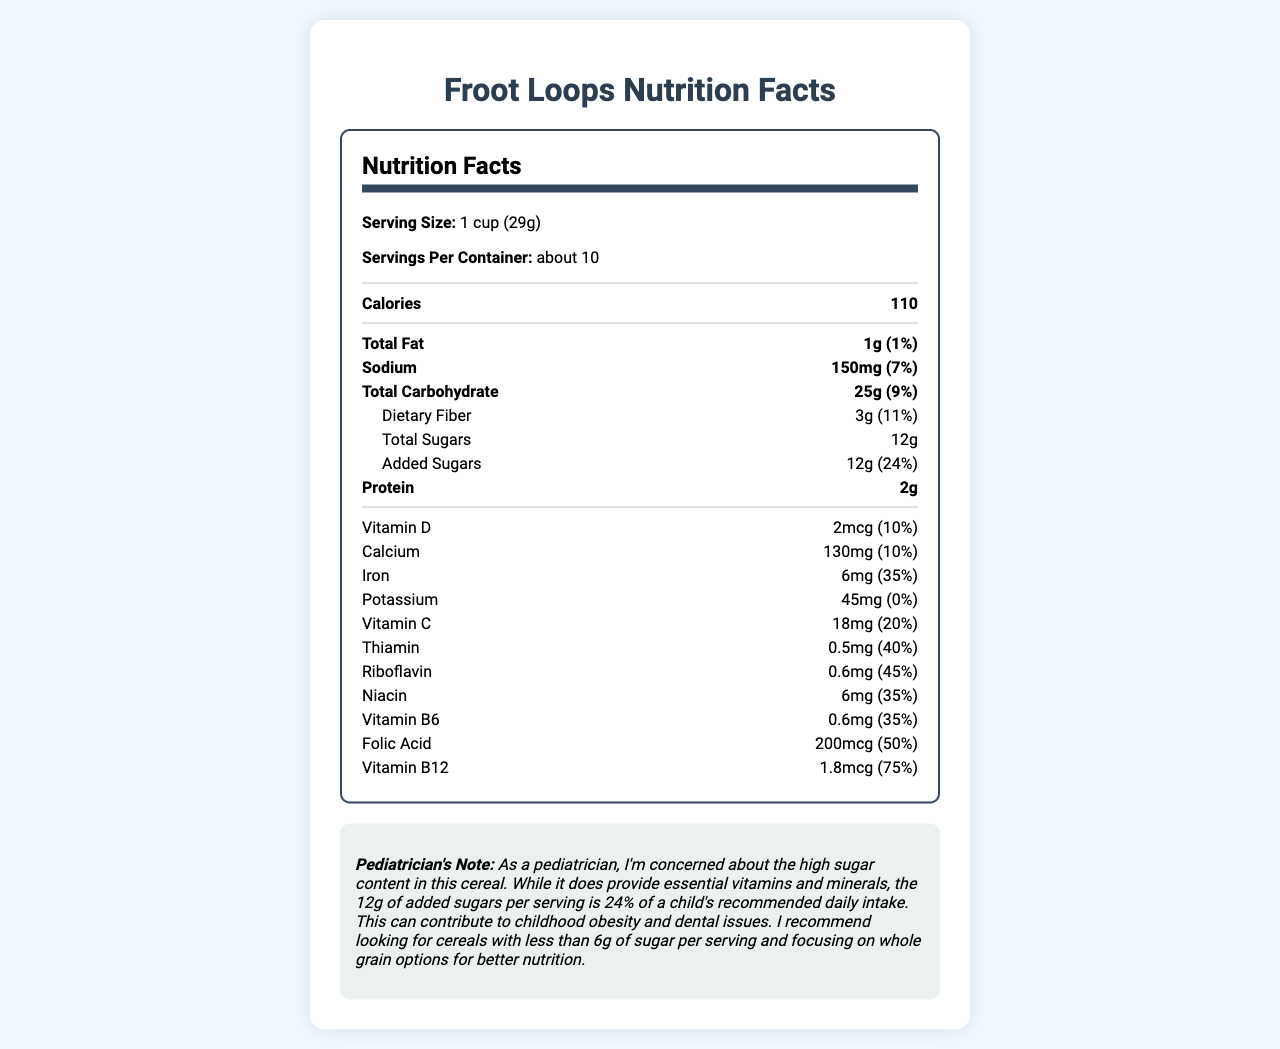how many grams of total sugars are in one serving of Froot Loops? The document lists "Total Sugars" as 12g per serving.
Answer: 12g what is the daily value percentage of added sugars in a serving of Froot Loops? The document states that the "Added Sugars" amount is 12g, which is 24% of the recommended daily intake.
Answer: 24% how much iron does one serving of Froot Loops provide? The "Iron" content in the document is listed as 6mg per serving.
Answer: 6mg how many calories are in one serving of Froot Loops? The document shows that there are 110 calories per serving.
Answer: 110 what is the serving size for Froot Loops? The document states that the serving size is "1 cup (29g)".
Answer: 1 cup (29g) which vitamin has the highest daily value percentage in one serving of Froot Loops? A. Vitamin D B. Vitamin C C. Folic Acid D. Vitamin B12 Vitamin B12 has a daily value percentage of 75%, the highest among the listed vitamins.
Answer: D. Vitamin B12 what is the recommended daily value percentage of calcium in one serving of this cereal? A. 5% B. 10% C. 20% D. 30% The document notes that one serving provides 10% of the recommended daily value for calcium.
Answer: B. 10% does one serving of Froot Loops provide any daily value percentage of potassium? The document indicates that the potassium content has a daily value percentage of 0%.
Answer: No summarize the main nutritional concerns mentioned by the pediatrician in the note related to Froot Loops. The pediatrician's note mentions concerns about the 12g of added sugars per serving (24% of daily intake) contributing to childhood obesity and dental issues, recommending cereals with less than 6g of sugar per serving and whole grain options for better nutrition.
Answer: High sugar content; recommends cereals with less than 6g of sugar per serving and to focus on whole grain options. calculate the total amount of sugars a child would consume if they ate three servings of Froot Loops. Each serving contains 12g of total sugars, so three servings would contain 3 * 12g = 36g.
Answer: 36g what is the total amount of protein in two servings of the cereal? One serving contains 2g of protein, so two servings would contain 2g * 2 = 4g.
Answer: 4g identify the nutrient that contributes the most to the daily recommended value and state the percentage. Vitamin B12 contributes 75% of the daily recommended value, which is the highest percentage among listed nutrients.
Answer: Vitamin B12, 75% is the cereal a good source of dietary fiber? The document indicates that one serving provides 11% of the daily value for dietary fiber, which is generally considered a good source.
Answer: Yes what are the main macronutrients listed in the document? The macronutrients listed are fat, sodium, carbohydrates (with subcategories), and protein.
Answer: Total Fat, Sodium, Total Carbohydrate (including Dietary Fiber and Total Sugars), and Protein how much thiamin can a child get from two servings? Each serving contains 0.5mg of thiamin, so two servings would provide 0.5mg * 2 = 1mg.
Answer: 1mg is there information on the type of grains used in Froot Loops? The document does not provide details about the type of grains used in Froot Loops.
Answer: Not enough information 